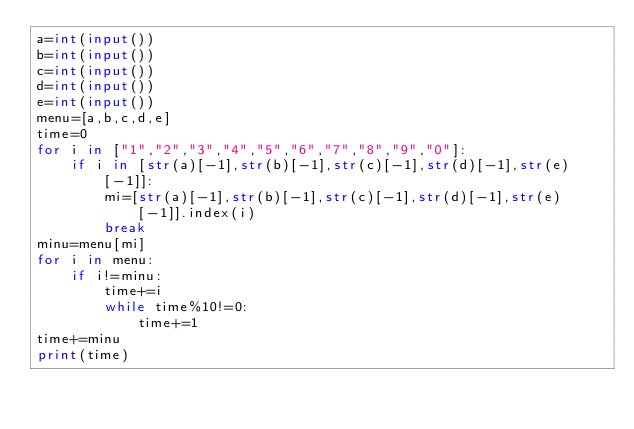Convert code to text. <code><loc_0><loc_0><loc_500><loc_500><_Python_>a=int(input())
b=int(input())
c=int(input())
d=int(input())
e=int(input())
menu=[a,b,c,d,e]
time=0
for i in ["1","2","3","4","5","6","7","8","9","0"]:
    if i in [str(a)[-1],str(b)[-1],str(c)[-1],str(d)[-1],str(e)[-1]]:
        mi=[str(a)[-1],str(b)[-1],str(c)[-1],str(d)[-1],str(e)[-1]].index(i)
        break
minu=menu[mi]
for i in menu:
    if i!=minu:
        time+=i
        while time%10!=0:
            time+=1
time+=minu
print(time)</code> 